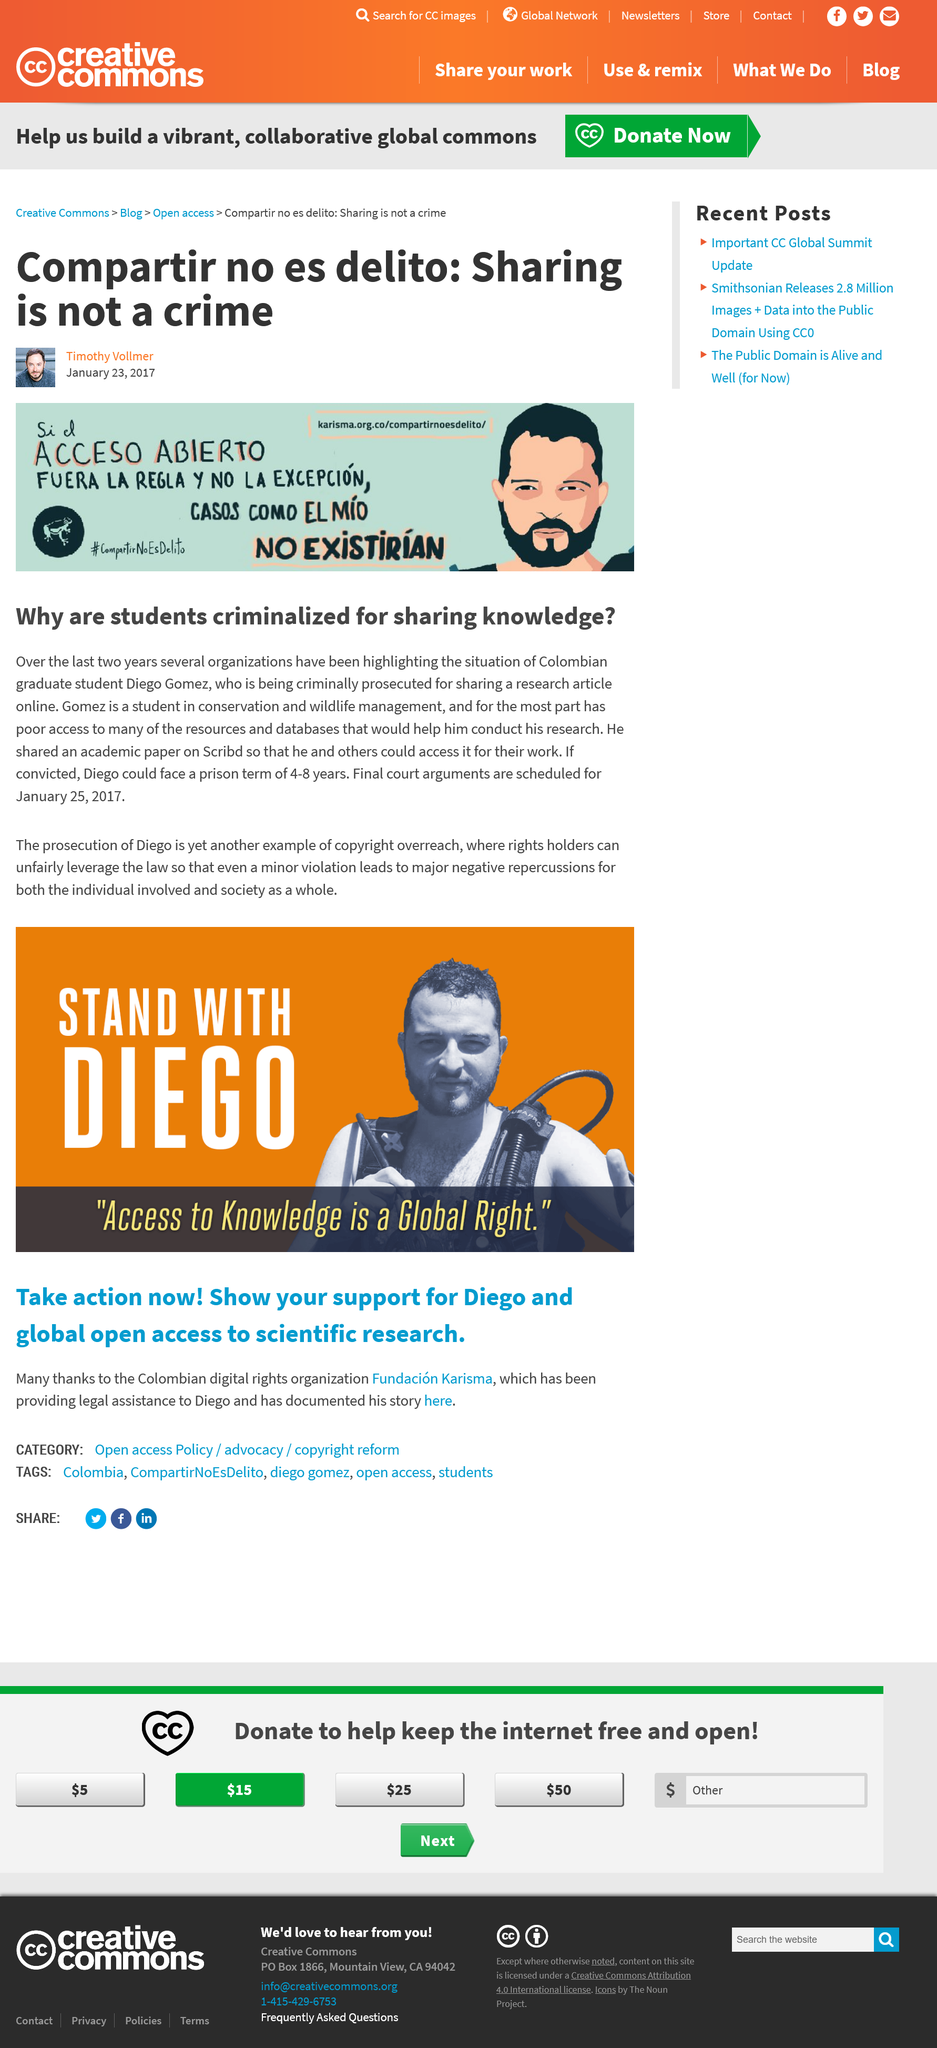Draw attention to some important aspects in this diagram. Gomez is currently pursuing a degree in Conservation and Wildlife Management, as demonstrated by his study focus. Gomez has been prosecuted for sharing a research article online. Diego could face a prison term of 4-8 years, according to potential sentencing guidelines. 